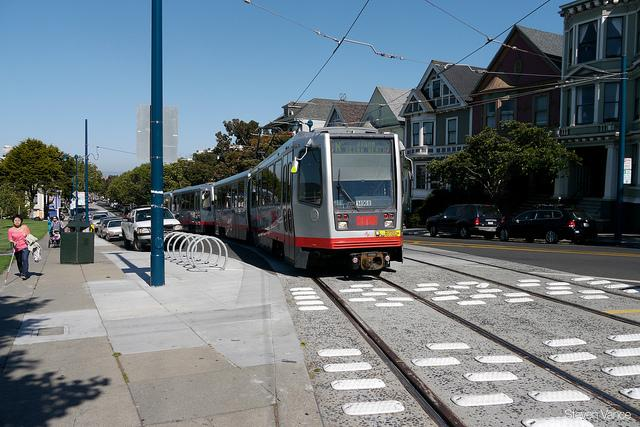The person nearest has what handicap? Please explain your reasoning. blindness. They have a stick. 